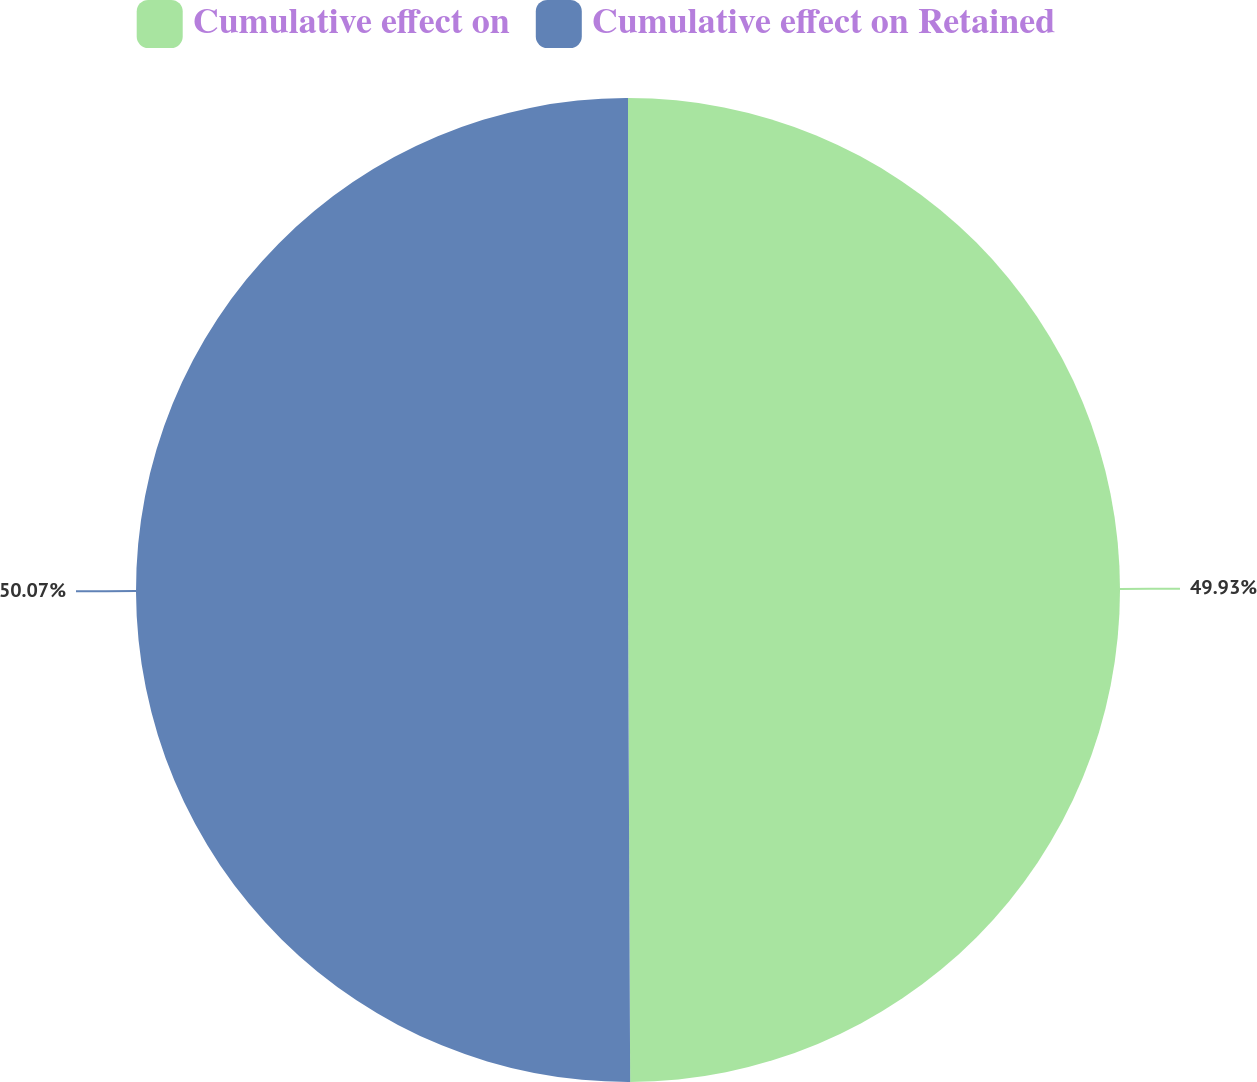Convert chart. <chart><loc_0><loc_0><loc_500><loc_500><pie_chart><fcel>Cumulative effect on<fcel>Cumulative effect on Retained<nl><fcel>49.93%<fcel>50.07%<nl></chart> 